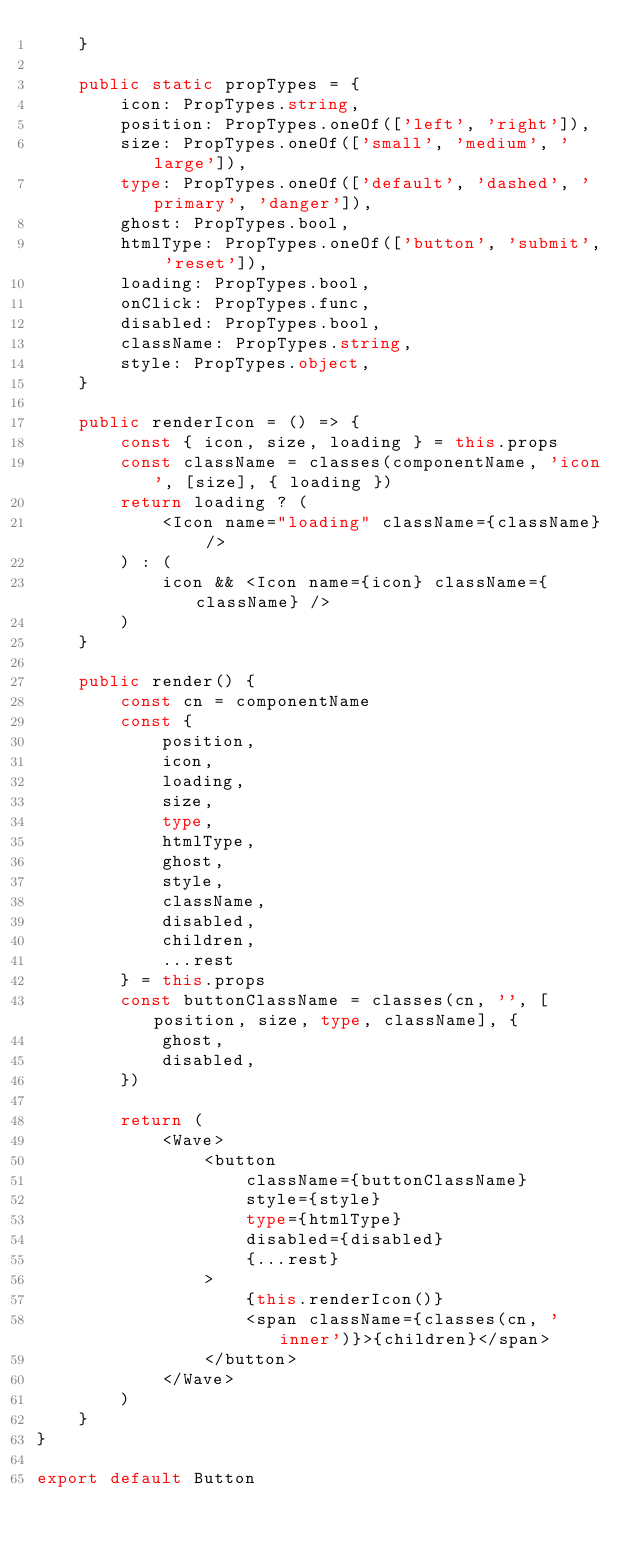Convert code to text. <code><loc_0><loc_0><loc_500><loc_500><_TypeScript_>	}

	public static propTypes = {
		icon: PropTypes.string,
		position: PropTypes.oneOf(['left', 'right']),
		size: PropTypes.oneOf(['small', 'medium', 'large']),
		type: PropTypes.oneOf(['default', 'dashed', 'primary', 'danger']),
		ghost: PropTypes.bool,
		htmlType: PropTypes.oneOf(['button', 'submit', 'reset']),
		loading: PropTypes.bool,
		onClick: PropTypes.func,
		disabled: PropTypes.bool,
		className: PropTypes.string,
		style: PropTypes.object,
	}

	public renderIcon = () => {
		const { icon, size, loading } = this.props
		const className = classes(componentName, 'icon', [size], { loading })
		return loading ? (
			<Icon name="loading" className={className} />
		) : (
			icon && <Icon name={icon} className={className} />
		)
	}

	public render() {
		const cn = componentName
		const {
			position,
			icon,
			loading,
			size,
			type,
			htmlType,
			ghost,
			style,
			className,
			disabled,
			children,
			...rest
		} = this.props
		const buttonClassName = classes(cn, '', [position, size, type, className], {
			ghost,
			disabled,
		})

		return (
			<Wave>
				<button
					className={buttonClassName}
					style={style}
					type={htmlType}
					disabled={disabled}
					{...rest}
				>
					{this.renderIcon()}
					<span className={classes(cn, 'inner')}>{children}</span>
				</button>
			</Wave>
		)
	}
}

export default Button
</code> 